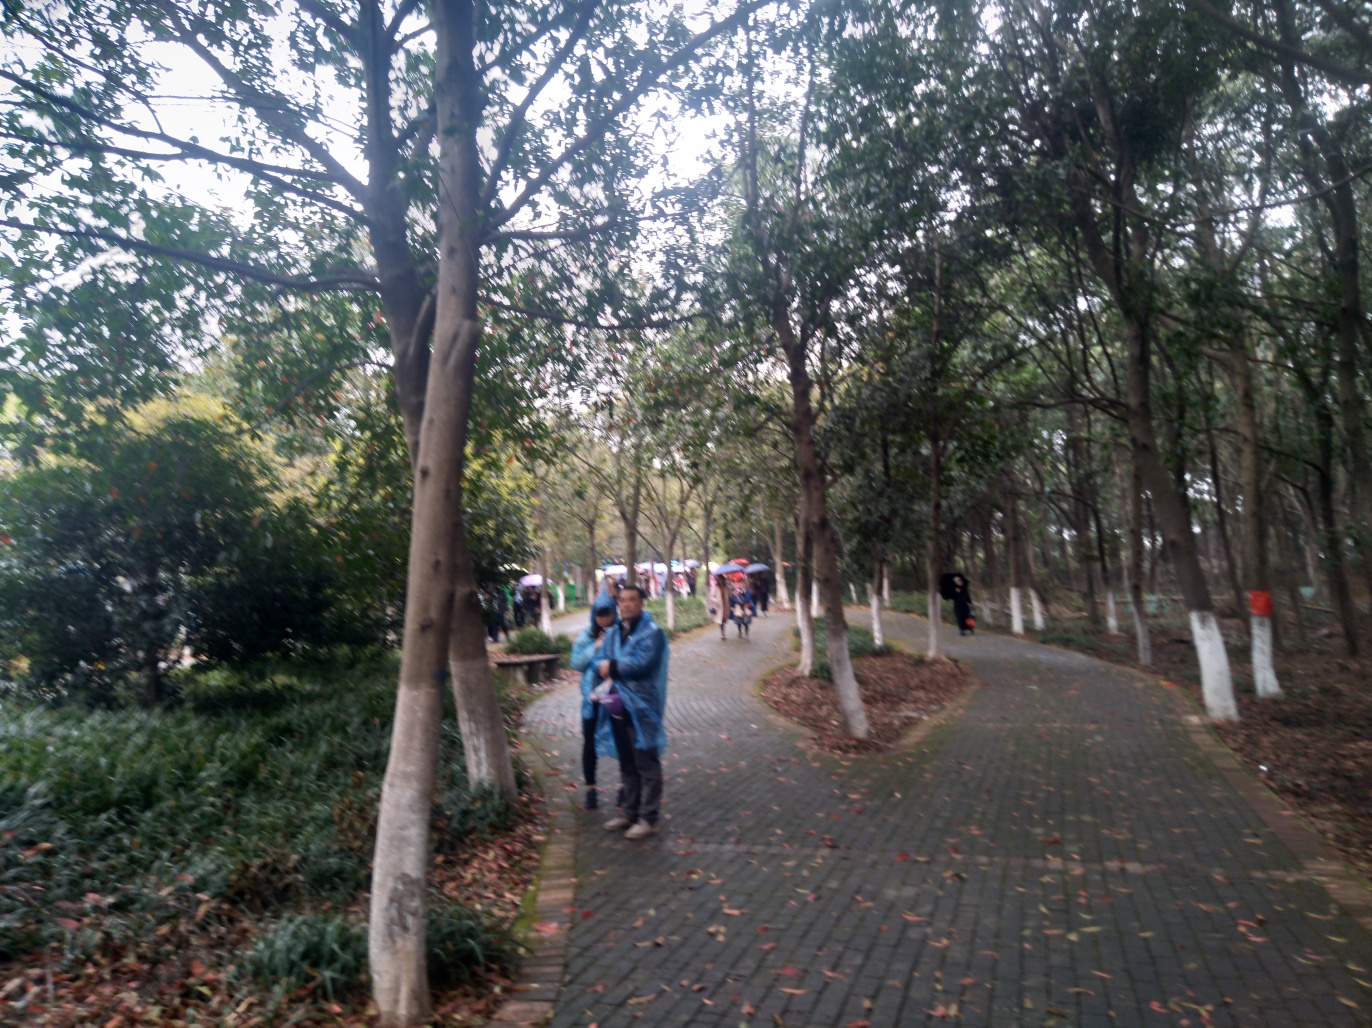What is the overall clarity of this image? The overall clarity of this image appears to be somewhat low. The photo is slightly out of focus, affecting the sharpness of the objects and people captured within the frame. Although the image is not completely blurry, the definition of the subjects, such as the people walking and the texture of the foliage, is not as crisp as it could be with a higher-resolution or more focused shot. 